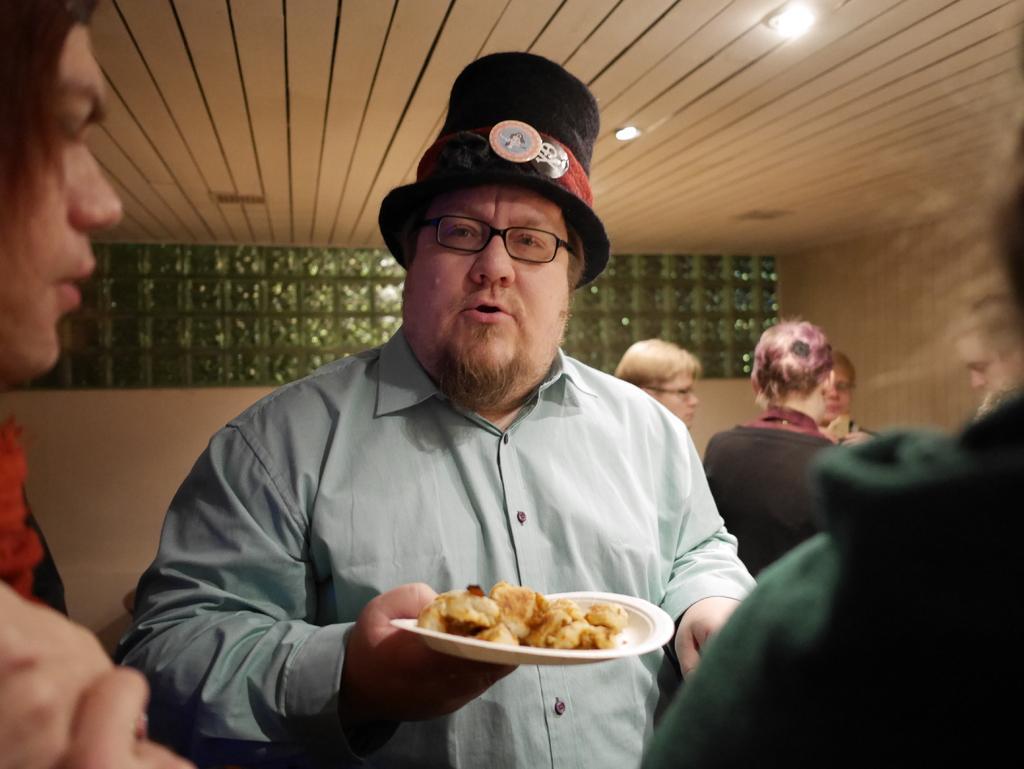In one or two sentences, can you explain what this image depicts? n this image we can see one person holding a plate with food items in it, beside we can see few people standing. And we can see the wall in the background, at the top we can see the ceiling with the lights. 